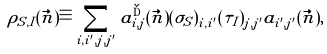Convert formula to latex. <formula><loc_0><loc_0><loc_500><loc_500>\rho _ { S , I } ( \vec { n } ) \equiv \sum _ { i , i ^ { \prime } , j , j ^ { \prime } } a _ { i , j } ^ { \dag } ( \vec { n } ) ( \sigma _ { S } ) _ { i , i ^ { \prime } } ( \tau _ { I } ) _ { j , j ^ { \prime } } a _ { i ^ { \prime } , j ^ { \prime } } ( \vec { n } ) ,</formula> 